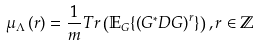Convert formula to latex. <formula><loc_0><loc_0><loc_500><loc_500>\mu _ { \Lambda } \left ( r \right ) = \frac { 1 } { m } T r \left ( \mathbb { E } _ { G } \{ \left ( G ^ { * } D G \right ) ^ { r } \} \right ) , r \in \mathbb { Z }</formula> 